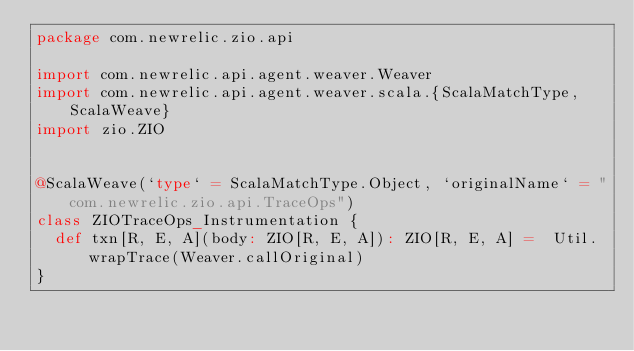<code> <loc_0><loc_0><loc_500><loc_500><_Scala_>package com.newrelic.zio.api

import com.newrelic.api.agent.weaver.Weaver
import com.newrelic.api.agent.weaver.scala.{ScalaMatchType, ScalaWeave}
import zio.ZIO


@ScalaWeave(`type` = ScalaMatchType.Object, `originalName` = "com.newrelic.zio.api.TraceOps")
class ZIOTraceOps_Instrumentation {
  def txn[R, E, A](body: ZIO[R, E, A]): ZIO[R, E, A] =  Util.wrapTrace(Weaver.callOriginal)
}
</code> 